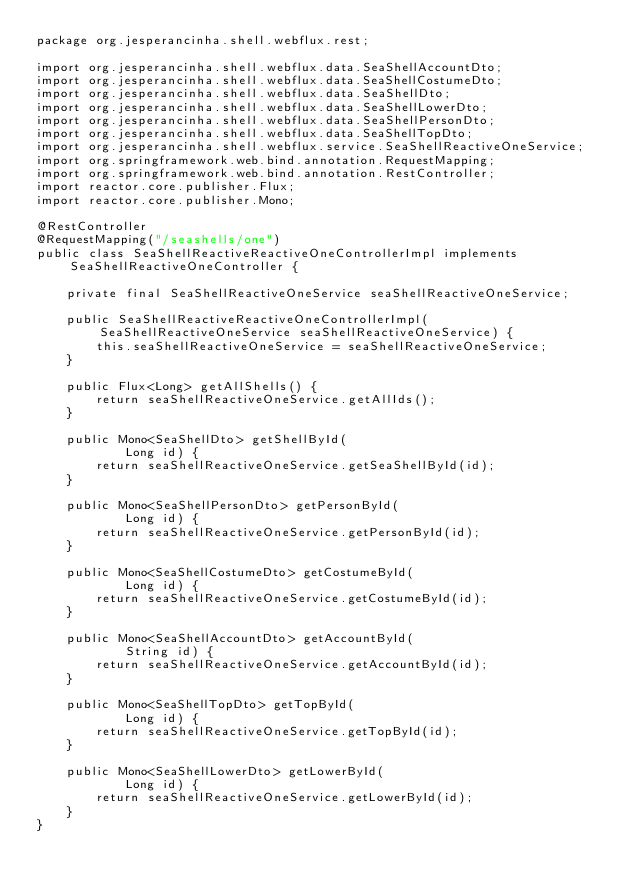Convert code to text. <code><loc_0><loc_0><loc_500><loc_500><_Java_>package org.jesperancinha.shell.webflux.rest;

import org.jesperancinha.shell.webflux.data.SeaShellAccountDto;
import org.jesperancinha.shell.webflux.data.SeaShellCostumeDto;
import org.jesperancinha.shell.webflux.data.SeaShellDto;
import org.jesperancinha.shell.webflux.data.SeaShellLowerDto;
import org.jesperancinha.shell.webflux.data.SeaShellPersonDto;
import org.jesperancinha.shell.webflux.data.SeaShellTopDto;
import org.jesperancinha.shell.webflux.service.SeaShellReactiveOneService;
import org.springframework.web.bind.annotation.RequestMapping;
import org.springframework.web.bind.annotation.RestController;
import reactor.core.publisher.Flux;
import reactor.core.publisher.Mono;

@RestController
@RequestMapping("/seashells/one")
public class SeaShellReactiveReactiveOneControllerImpl implements SeaShellReactiveOneController {

    private final SeaShellReactiveOneService seaShellReactiveOneService;

    public SeaShellReactiveReactiveOneControllerImpl(SeaShellReactiveOneService seaShellReactiveOneService) {
        this.seaShellReactiveOneService = seaShellReactiveOneService;
    }

    public Flux<Long> getAllShells() {
        return seaShellReactiveOneService.getAllIds();
    }

    public Mono<SeaShellDto> getShellById(
            Long id) {
        return seaShellReactiveOneService.getSeaShellById(id);
    }

    public Mono<SeaShellPersonDto> getPersonById(
            Long id) {
        return seaShellReactiveOneService.getPersonById(id);
    }

    public Mono<SeaShellCostumeDto> getCostumeById(
            Long id) {
        return seaShellReactiveOneService.getCostumeById(id);
    }

    public Mono<SeaShellAccountDto> getAccountById(
            String id) {
        return seaShellReactiveOneService.getAccountById(id);
    }

    public Mono<SeaShellTopDto> getTopById(
            Long id) {
        return seaShellReactiveOneService.getTopById(id);
    }

    public Mono<SeaShellLowerDto> getLowerById(
            Long id) {
        return seaShellReactiveOneService.getLowerById(id);
    }
}
</code> 